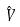Convert formula to latex. <formula><loc_0><loc_0><loc_500><loc_500>\hat { V }</formula> 